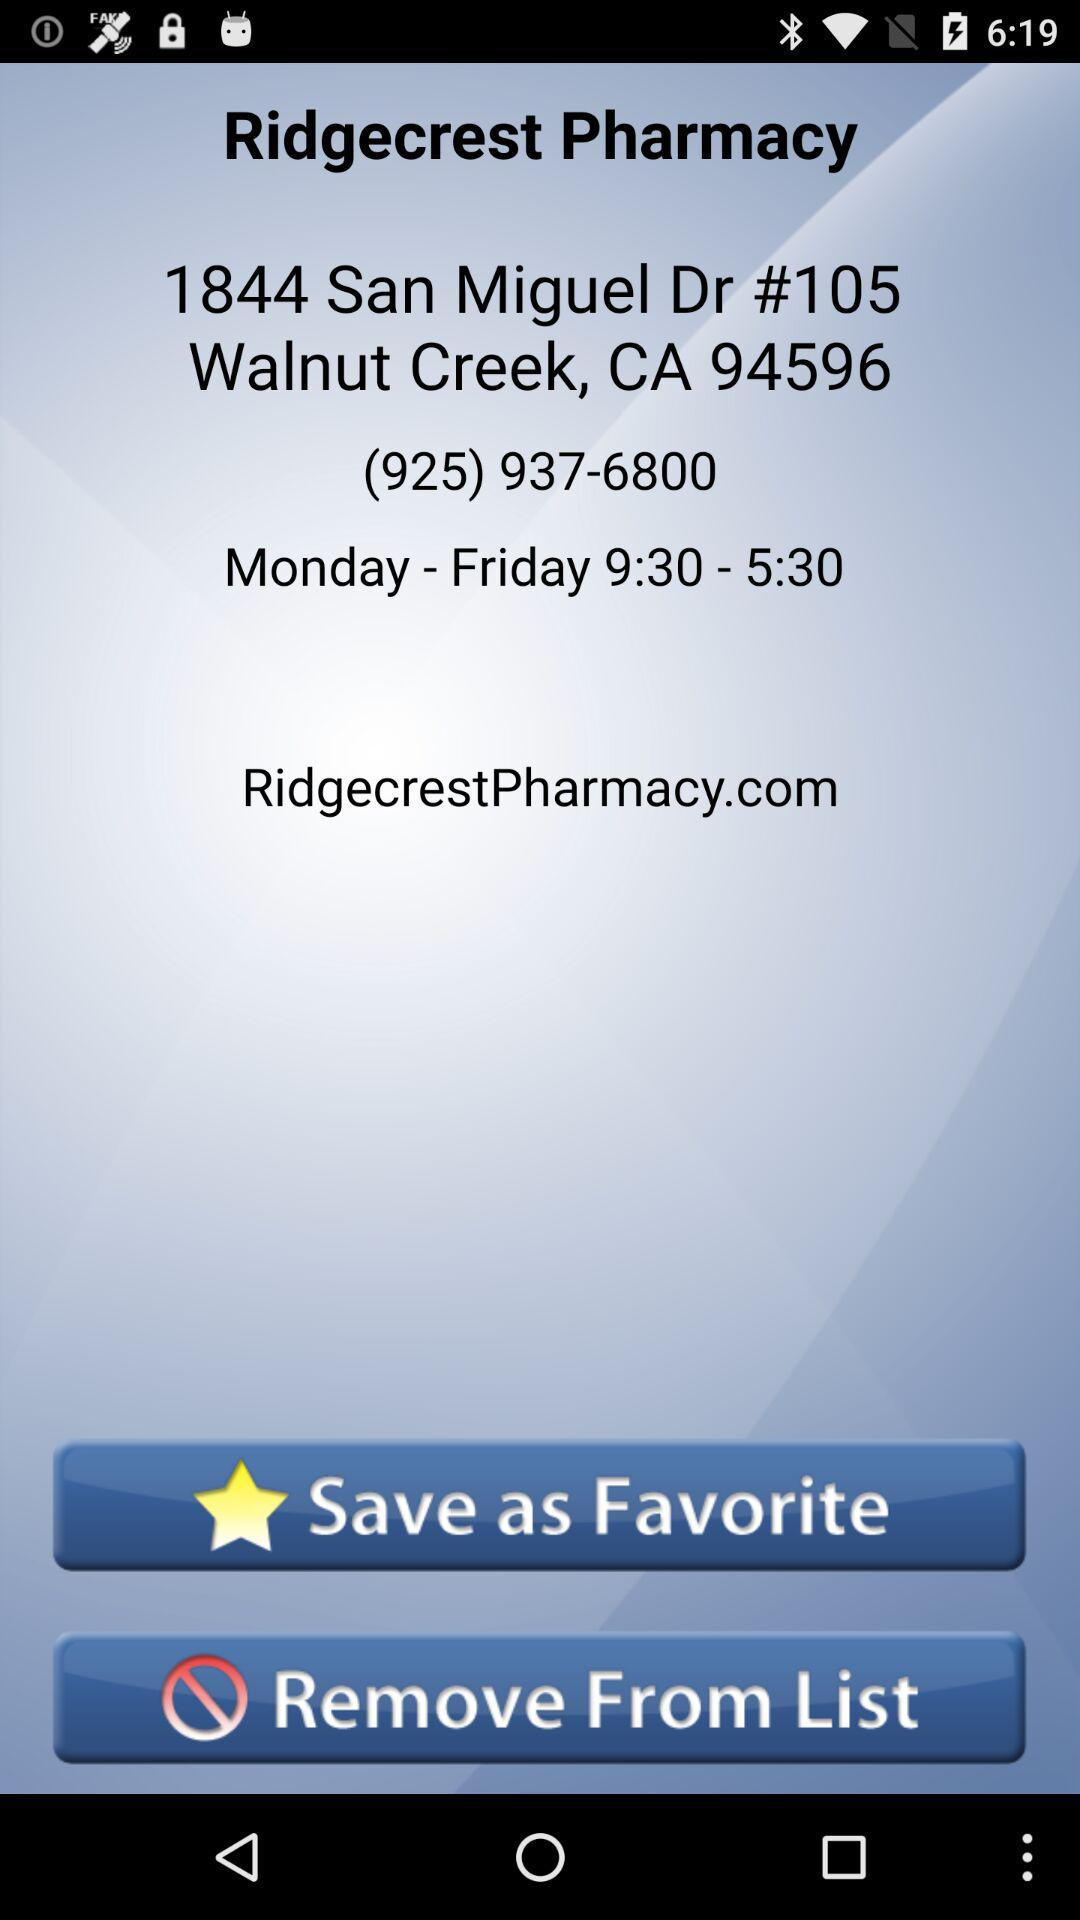What are the visiting hours for "Ridgecrest Pharmacy"? The visiting hours for "Ridgecrest Pharmacy" is from 9:30 to 5:30. 